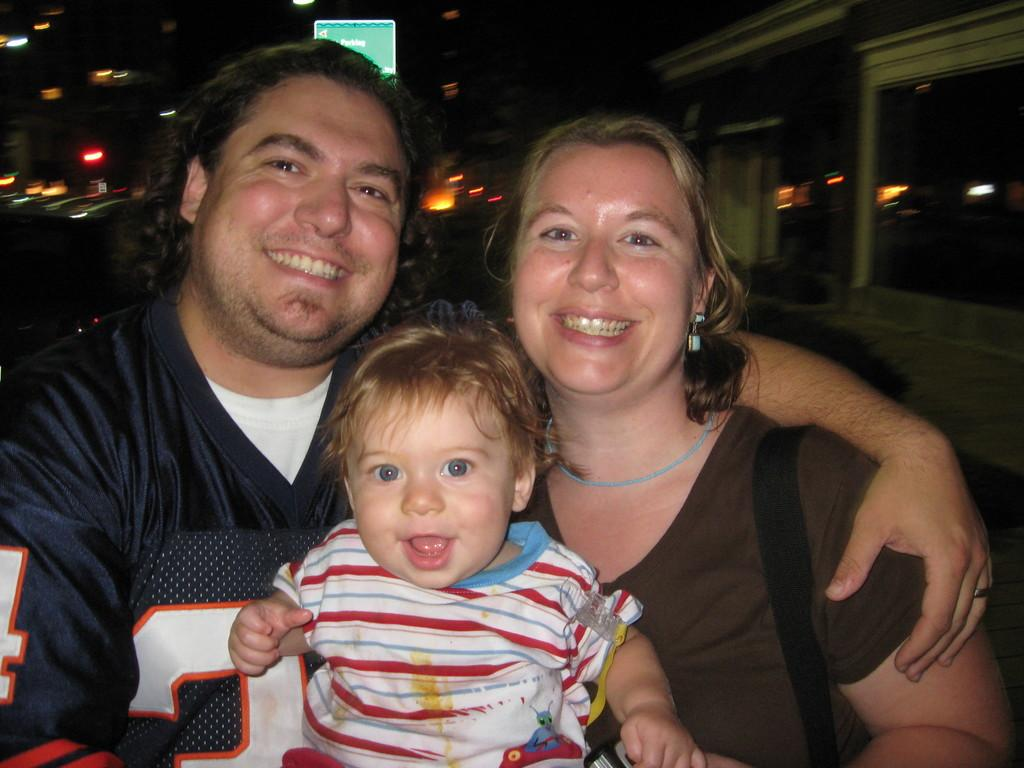How many people are in the image? There are three people in the image. What are the people doing in the image? The people are sitting. Can you describe the lighting in the image? There are lights on the ceiling in the image. What type of book is the writer holding in the image? There is no writer or book present in the image. How many women are in the image? The provided facts do not specify the gender of the people in the image, so we cannot determine the number of women. 